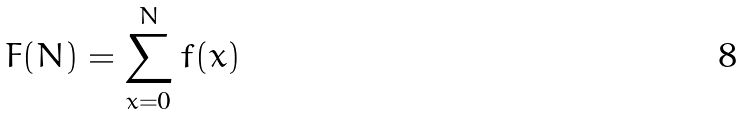<formula> <loc_0><loc_0><loc_500><loc_500>F ( N ) = \sum _ { x = 0 } ^ { N } f ( x )</formula> 